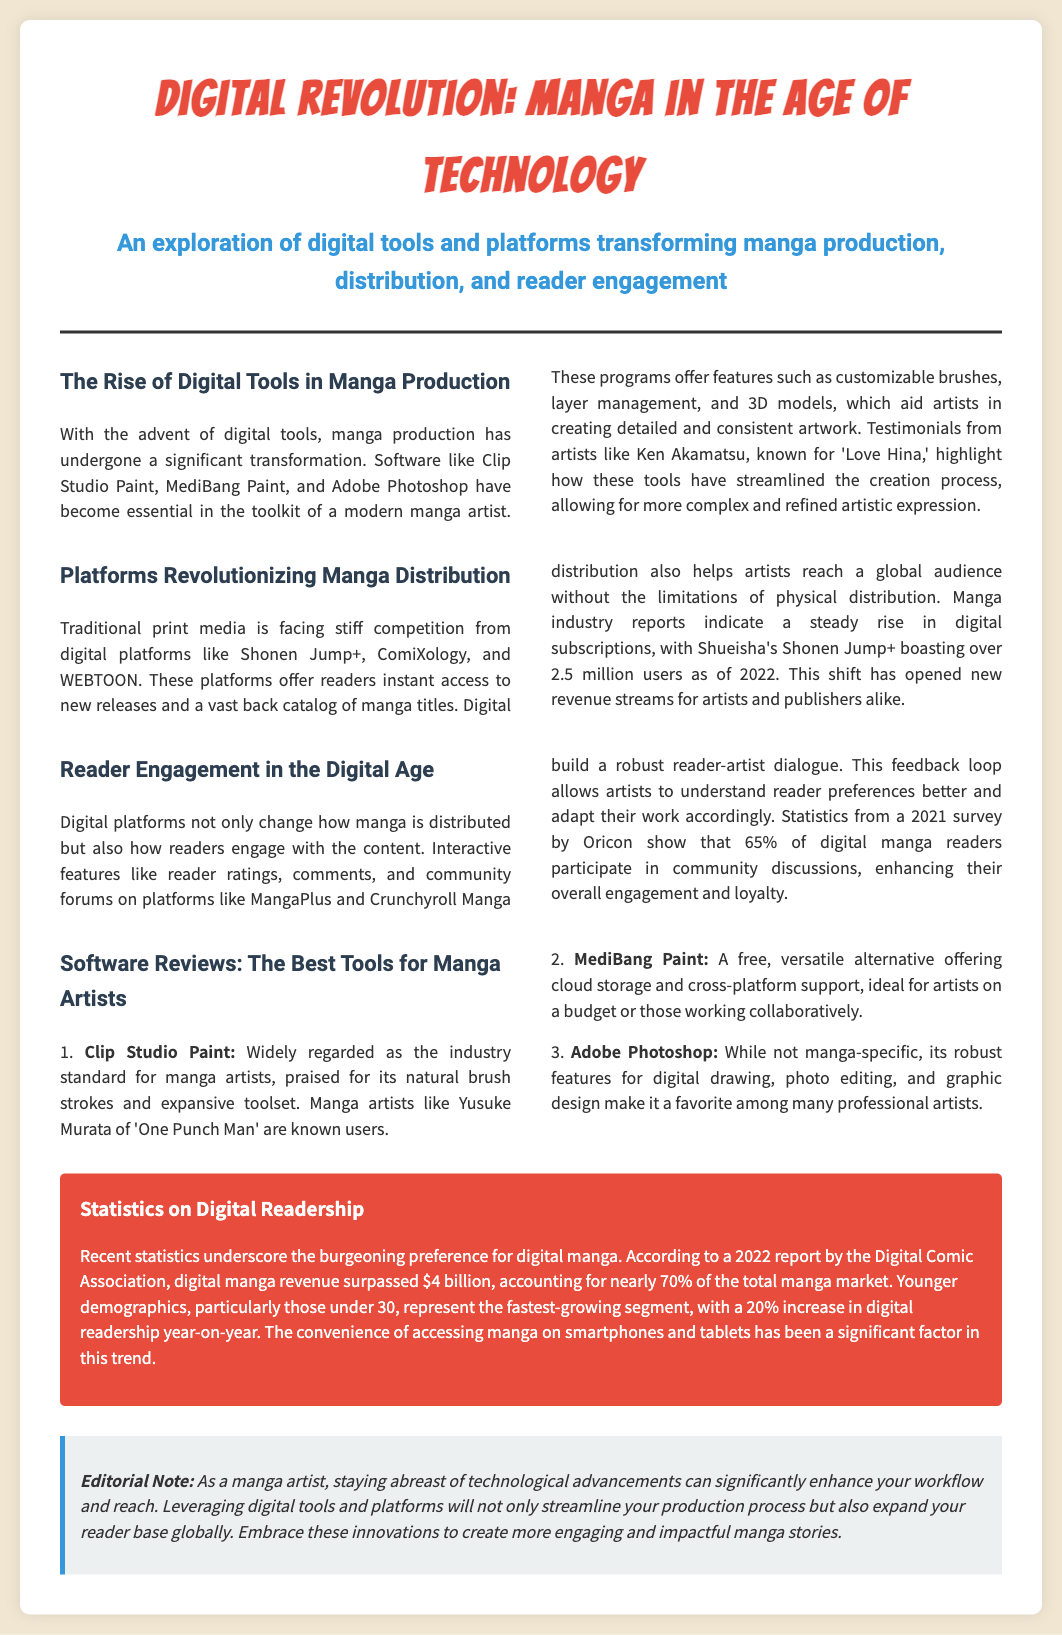What is the primary software mentioned for manga production? The primary software discussed in the document for manga production includes Clip Studio Paint, MediBang Paint, and Adobe Photoshop.
Answer: Clip Studio Paint How many users does Shonen Jump+ have as of 2022? The document states that Shonen Jump+ boasts over 2.5 million users as of 2022.
Answer: 2.5 million Which artist is known for highlighting the benefits of digital tools in the document? The document mentions Ken Akamatsu, known for 'Love Hina,' highlighting the benefits of digital tools for manga production.
Answer: Ken Akamatsu What percentage of digital manga readers participate in community discussions according to the document? A statistic from a 2021 survey indicates that 65% of digital manga readers participate in community discussions.
Answer: 65% What is the estimated digital manga revenue reported in 2022? According to a 2022 report, the digital manga revenue surpassed $4 billion.
Answer: $4 billion Why are younger demographics (under 30) significant in the context of digital readership? The document notes that younger demographics represent the fastest-growing segment of digital readership, with a 20% increase year-on-year.
Answer: Fastest-growing segment What color is used for the background of the statistics section? The statistics section has a background color of red (#e74c3c) according to the styling details in the document.
Answer: Red Which software is recognized as the industry standard for manga artists? The document identifies Clip Studio Paint as widely regarded as the industry standard for manga artists.
Answer: Clip Studio Paint What is noted in the editorial section regarding technological advancements? The editorial note emphasizes that staying abreast of technological advancements can significantly enhance workflow and reach.
Answer: Enhance workflow and reach 